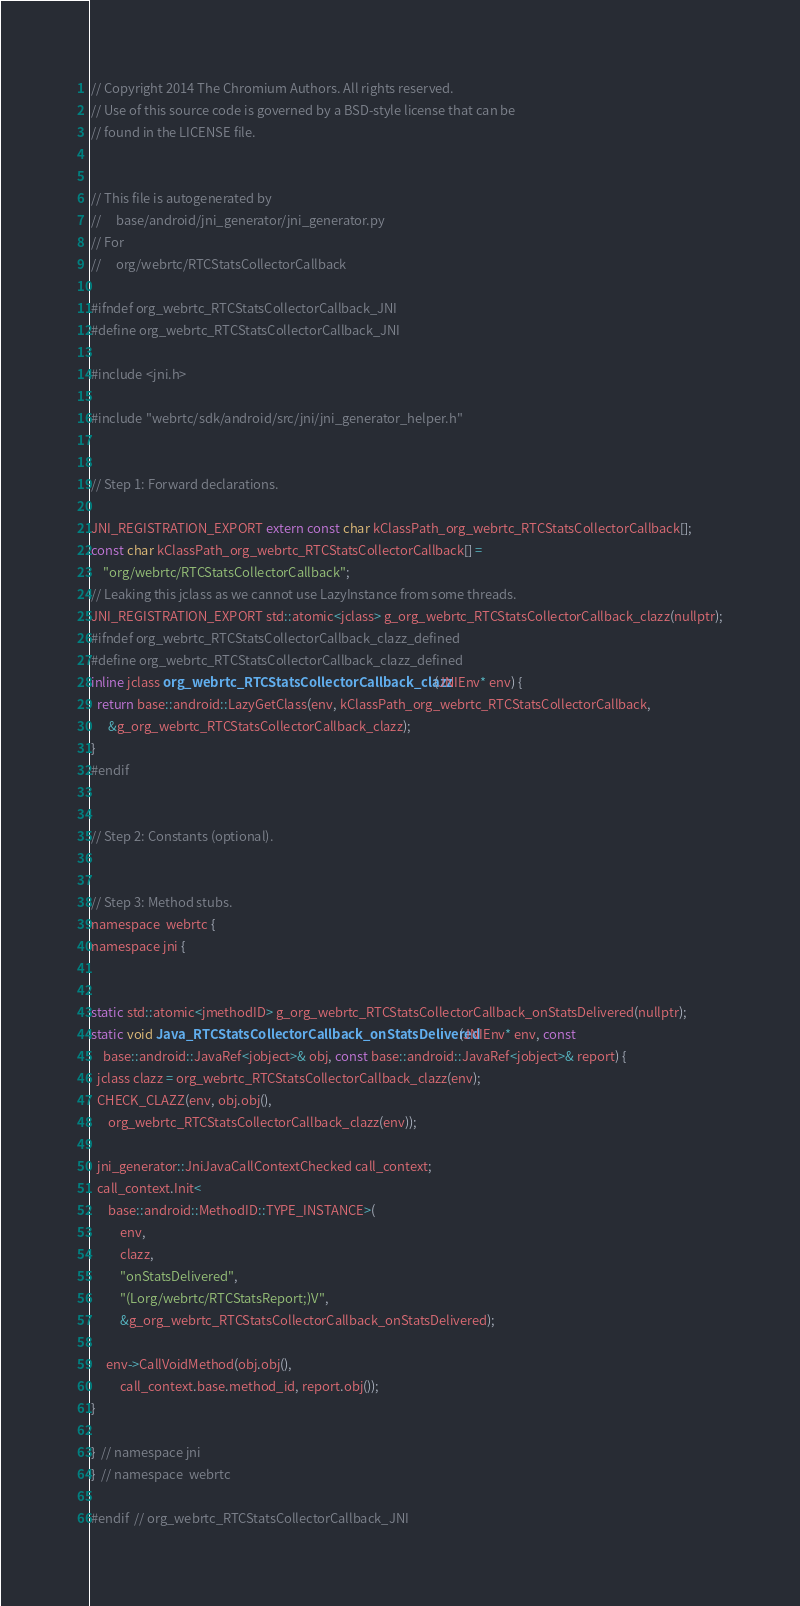Convert code to text. <code><loc_0><loc_0><loc_500><loc_500><_C_>// Copyright 2014 The Chromium Authors. All rights reserved.
// Use of this source code is governed by a BSD-style license that can be
// found in the LICENSE file.


// This file is autogenerated by
//     base/android/jni_generator/jni_generator.py
// For
//     org/webrtc/RTCStatsCollectorCallback

#ifndef org_webrtc_RTCStatsCollectorCallback_JNI
#define org_webrtc_RTCStatsCollectorCallback_JNI

#include <jni.h>

#include "webrtc/sdk/android/src/jni/jni_generator_helper.h"


// Step 1: Forward declarations.

JNI_REGISTRATION_EXPORT extern const char kClassPath_org_webrtc_RTCStatsCollectorCallback[];
const char kClassPath_org_webrtc_RTCStatsCollectorCallback[] =
    "org/webrtc/RTCStatsCollectorCallback";
// Leaking this jclass as we cannot use LazyInstance from some threads.
JNI_REGISTRATION_EXPORT std::atomic<jclass> g_org_webrtc_RTCStatsCollectorCallback_clazz(nullptr);
#ifndef org_webrtc_RTCStatsCollectorCallback_clazz_defined
#define org_webrtc_RTCStatsCollectorCallback_clazz_defined
inline jclass org_webrtc_RTCStatsCollectorCallback_clazz(JNIEnv* env) {
  return base::android::LazyGetClass(env, kClassPath_org_webrtc_RTCStatsCollectorCallback,
      &g_org_webrtc_RTCStatsCollectorCallback_clazz);
}
#endif


// Step 2: Constants (optional).


// Step 3: Method stubs.
namespace  webrtc {
namespace jni {


static std::atomic<jmethodID> g_org_webrtc_RTCStatsCollectorCallback_onStatsDelivered(nullptr);
static void Java_RTCStatsCollectorCallback_onStatsDelivered(JNIEnv* env, const
    base::android::JavaRef<jobject>& obj, const base::android::JavaRef<jobject>& report) {
  jclass clazz = org_webrtc_RTCStatsCollectorCallback_clazz(env);
  CHECK_CLAZZ(env, obj.obj(),
      org_webrtc_RTCStatsCollectorCallback_clazz(env));

  jni_generator::JniJavaCallContextChecked call_context;
  call_context.Init<
      base::android::MethodID::TYPE_INSTANCE>(
          env,
          clazz,
          "onStatsDelivered",
          "(Lorg/webrtc/RTCStatsReport;)V",
          &g_org_webrtc_RTCStatsCollectorCallback_onStatsDelivered);

     env->CallVoidMethod(obj.obj(),
          call_context.base.method_id, report.obj());
}

}  // namespace jni
}  // namespace  webrtc

#endif  // org_webrtc_RTCStatsCollectorCallback_JNI
</code> 